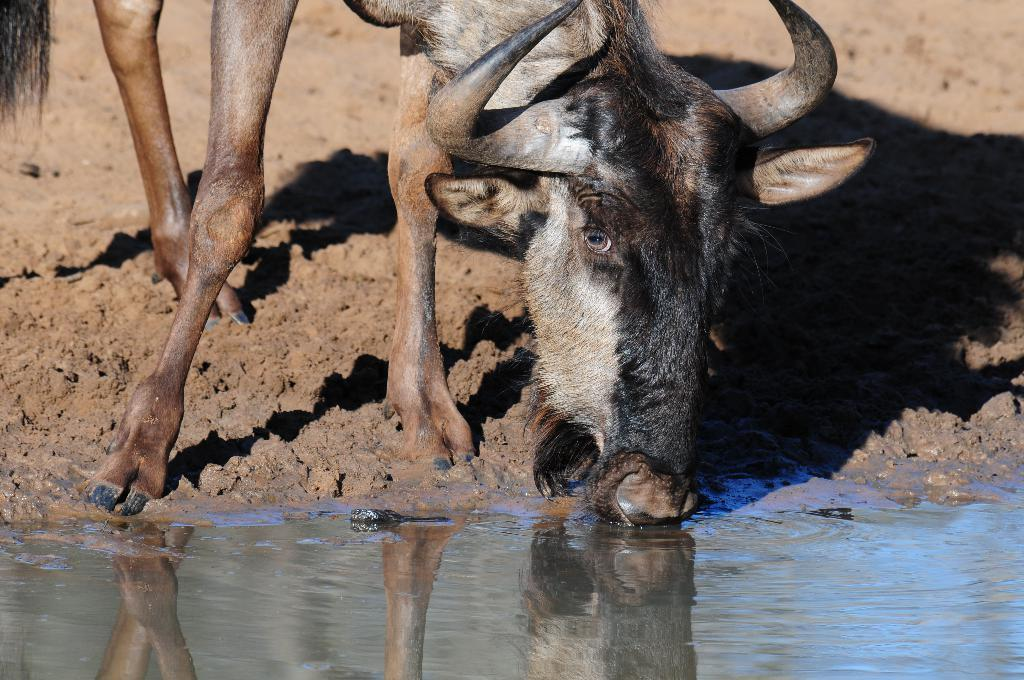What animal is present in the image? There is a buffalo in the image. What is the buffalo doing in the image? The buffalo is drinking water. Where is the shelf located in the image? There is no shelf present in the image. What type of front is visible on the buffalo in the image? The image does not show any specific front on the buffalo; it only shows the buffalo drinking water. 